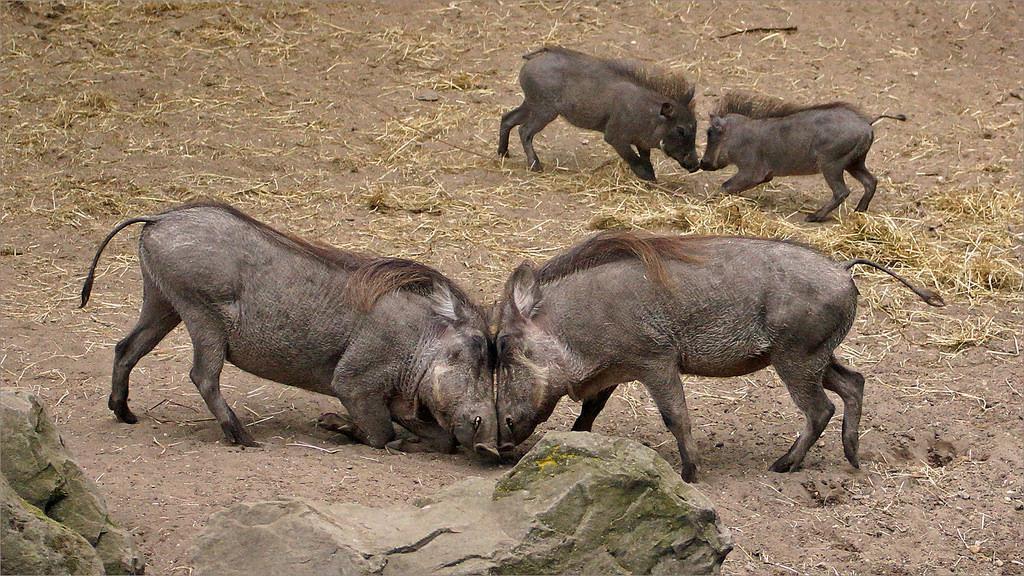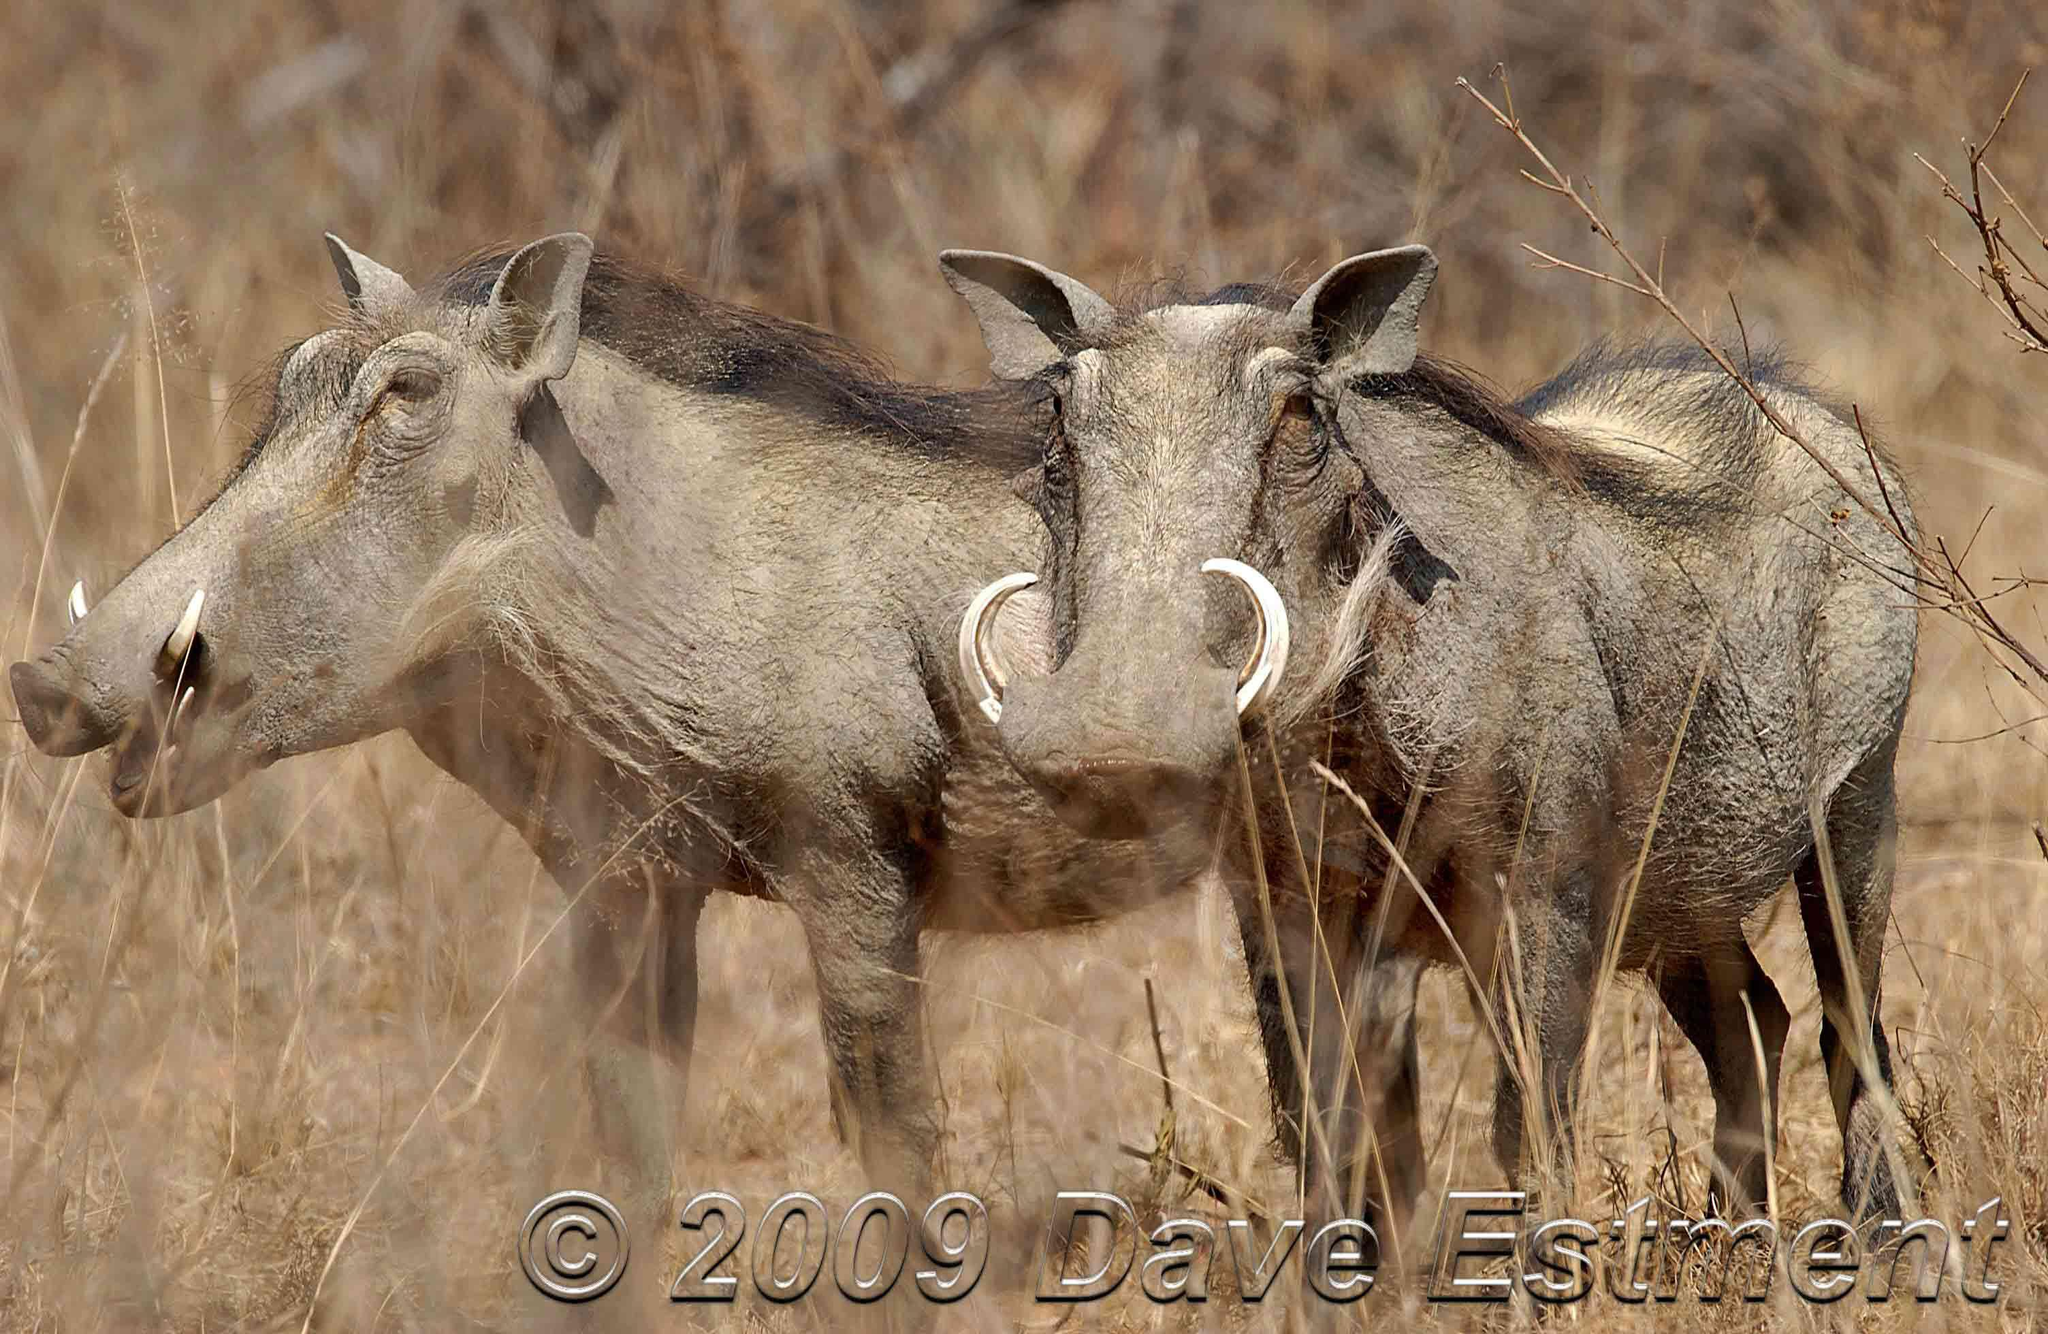The first image is the image on the left, the second image is the image on the right. For the images displayed, is the sentence "In one image two warthog is drinking out of a lake." factually correct? Answer yes or no. No. The first image is the image on the left, the second image is the image on the right. Evaluate the accuracy of this statement regarding the images: "There are two wart hogs in the right image that are both facing towards the left.". Is it true? Answer yes or no. Yes. 